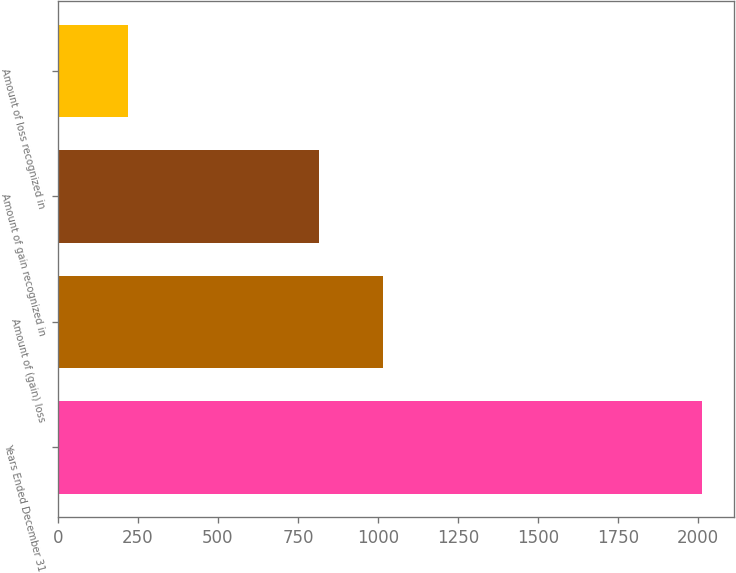<chart> <loc_0><loc_0><loc_500><loc_500><bar_chart><fcel>Years Ended December 31<fcel>Amount of (gain) loss<fcel>Amount of gain recognized in<fcel>Amount of loss recognized in<nl><fcel>2012<fcel>1016<fcel>816.8<fcel>219.2<nl></chart> 